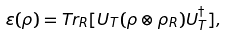Convert formula to latex. <formula><loc_0><loc_0><loc_500><loc_500>\varepsilon ( \rho ) = T r _ { R } [ U _ { T } ( \rho \otimes \rho _ { R } ) U _ { T } ^ { \dagger } ] ,</formula> 